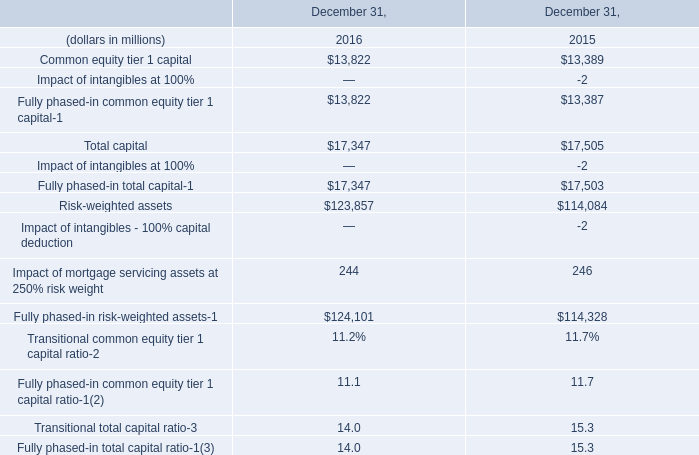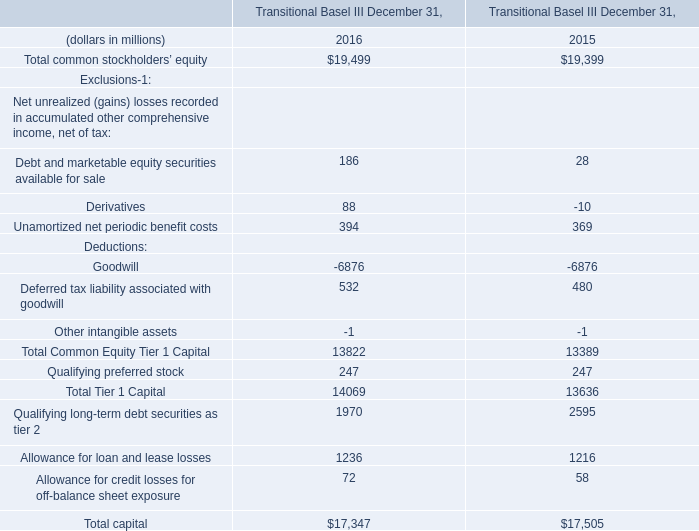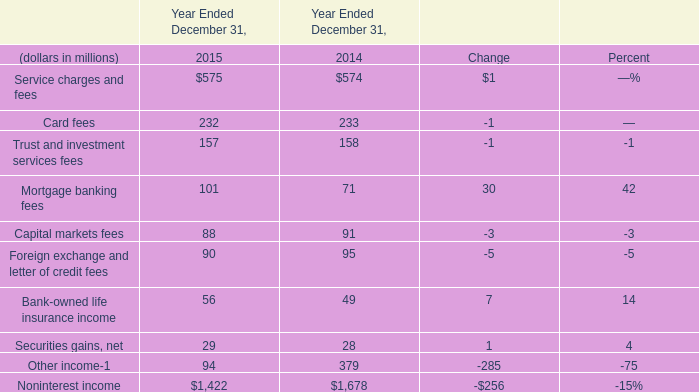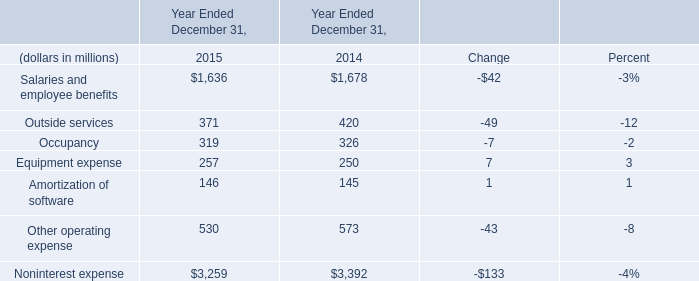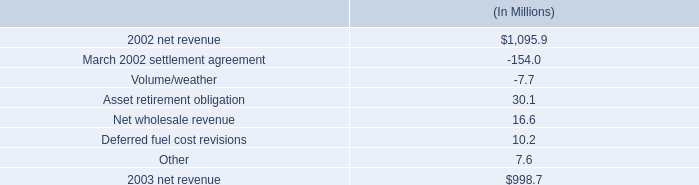what is the storm damage cost as a percentage of 2002 net revenue? 
Computations: (195 / 1095.9)
Answer: 0.17794. 